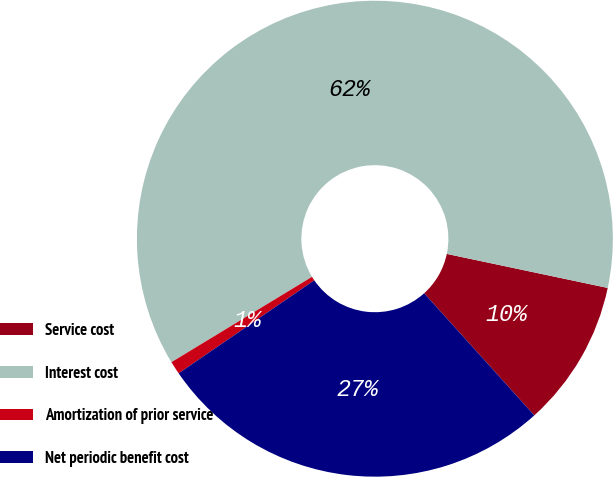Convert chart. <chart><loc_0><loc_0><loc_500><loc_500><pie_chart><fcel>Service cost<fcel>Interest cost<fcel>Amortization of prior service<fcel>Net periodic benefit cost<nl><fcel>10.0%<fcel>62.0%<fcel>0.89%<fcel>27.11%<nl></chart> 